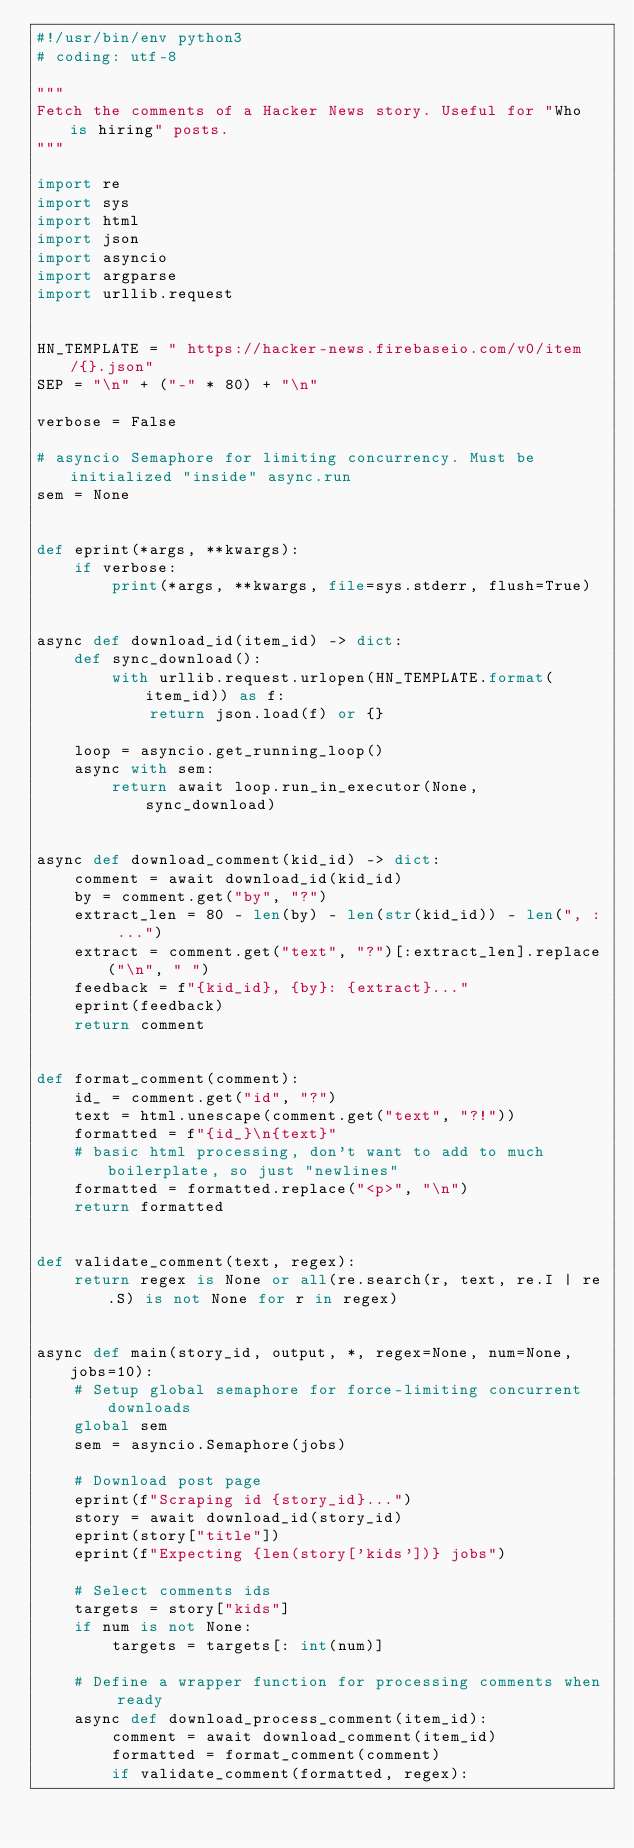Convert code to text. <code><loc_0><loc_0><loc_500><loc_500><_Python_>#!/usr/bin/env python3
# coding: utf-8

"""
Fetch the comments of a Hacker News story. Useful for "Who is hiring" posts.
"""

import re
import sys
import html
import json
import asyncio
import argparse
import urllib.request


HN_TEMPLATE = " https://hacker-news.firebaseio.com/v0/item/{}.json"
SEP = "\n" + ("-" * 80) + "\n"

verbose = False

# asyncio Semaphore for limiting concurrency. Must be initialized "inside" async.run
sem = None


def eprint(*args, **kwargs):
    if verbose:
        print(*args, **kwargs, file=sys.stderr, flush=True)


async def download_id(item_id) -> dict:
    def sync_download():
        with urllib.request.urlopen(HN_TEMPLATE.format(item_id)) as f:
            return json.load(f) or {}

    loop = asyncio.get_running_loop()
    async with sem:
        return await loop.run_in_executor(None, sync_download)


async def download_comment(kid_id) -> dict:
    comment = await download_id(kid_id)
    by = comment.get("by", "?")
    extract_len = 80 - len(by) - len(str(kid_id)) - len(", : ...")
    extract = comment.get("text", "?")[:extract_len].replace("\n", " ")
    feedback = f"{kid_id}, {by}: {extract}..."
    eprint(feedback)
    return comment


def format_comment(comment):
    id_ = comment.get("id", "?")
    text = html.unescape(comment.get("text", "?!"))
    formatted = f"{id_}\n{text}"
    # basic html processing, don't want to add to much boilerplate, so just "newlines"
    formatted = formatted.replace("<p>", "\n")
    return formatted


def validate_comment(text, regex):
    return regex is None or all(re.search(r, text, re.I | re.S) is not None for r in regex)


async def main(story_id, output, *, regex=None, num=None, jobs=10):
    # Setup global semaphore for force-limiting concurrent downloads
    global sem
    sem = asyncio.Semaphore(jobs)

    # Download post page
    eprint(f"Scraping id {story_id}...")
    story = await download_id(story_id)
    eprint(story["title"])
    eprint(f"Expecting {len(story['kids'])} jobs")

    # Select comments ids
    targets = story["kids"]
    if num is not None:
        targets = targets[: int(num)]

    # Define a wrapper function for processing comments when ready
    async def download_process_comment(item_id):
        comment = await download_comment(item_id)
        formatted = format_comment(comment)
        if validate_comment(formatted, regex):</code> 